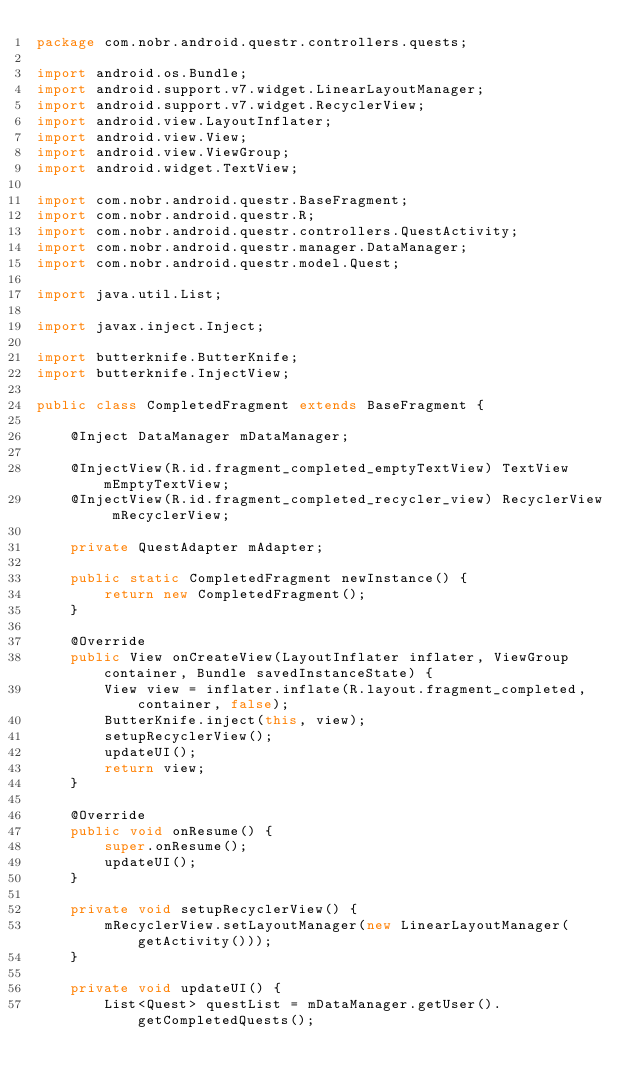Convert code to text. <code><loc_0><loc_0><loc_500><loc_500><_Java_>package com.nobr.android.questr.controllers.quests;

import android.os.Bundle;
import android.support.v7.widget.LinearLayoutManager;
import android.support.v7.widget.RecyclerView;
import android.view.LayoutInflater;
import android.view.View;
import android.view.ViewGroup;
import android.widget.TextView;

import com.nobr.android.questr.BaseFragment;
import com.nobr.android.questr.R;
import com.nobr.android.questr.controllers.QuestActivity;
import com.nobr.android.questr.manager.DataManager;
import com.nobr.android.questr.model.Quest;

import java.util.List;

import javax.inject.Inject;

import butterknife.ButterKnife;
import butterknife.InjectView;

public class CompletedFragment extends BaseFragment {

    @Inject DataManager mDataManager;

    @InjectView(R.id.fragment_completed_emptyTextView) TextView mEmptyTextView;
    @InjectView(R.id.fragment_completed_recycler_view) RecyclerView mRecyclerView;

    private QuestAdapter mAdapter;

    public static CompletedFragment newInstance() {
        return new CompletedFragment();
    }

    @Override
    public View onCreateView(LayoutInflater inflater, ViewGroup container, Bundle savedInstanceState) {
        View view = inflater.inflate(R.layout.fragment_completed, container, false);
        ButterKnife.inject(this, view);
        setupRecyclerView();
        updateUI();
        return view;
    }

    @Override
    public void onResume() {
        super.onResume();
        updateUI();
    }

    private void setupRecyclerView() {
        mRecyclerView.setLayoutManager(new LinearLayoutManager(getActivity()));
    }

    private void updateUI() {
        List<Quest> questList = mDataManager.getUser().getCompletedQuests();</code> 